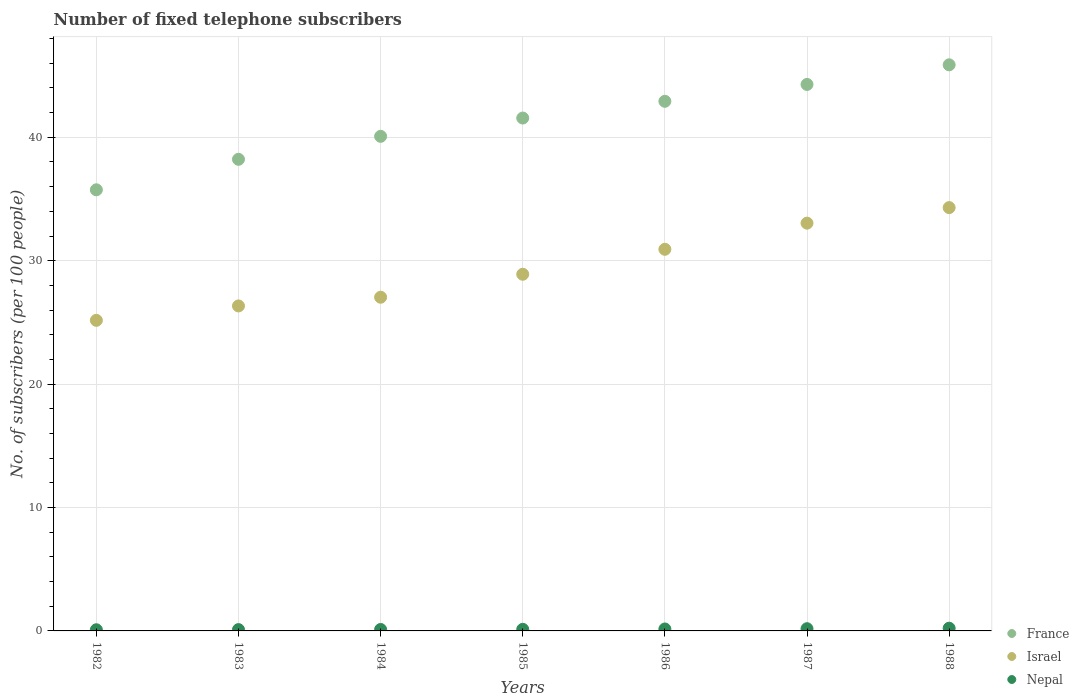Is the number of dotlines equal to the number of legend labels?
Offer a terse response. Yes. What is the number of fixed telephone subscribers in Nepal in 1986?
Make the answer very short. 0.16. Across all years, what is the maximum number of fixed telephone subscribers in Israel?
Your answer should be very brief. 34.3. Across all years, what is the minimum number of fixed telephone subscribers in Israel?
Offer a terse response. 25.17. What is the total number of fixed telephone subscribers in France in the graph?
Your answer should be compact. 288.67. What is the difference between the number of fixed telephone subscribers in France in 1985 and that in 1987?
Offer a very short reply. -2.72. What is the difference between the number of fixed telephone subscribers in Israel in 1988 and the number of fixed telephone subscribers in France in 1983?
Your answer should be very brief. -3.91. What is the average number of fixed telephone subscribers in Nepal per year?
Your response must be concise. 0.14. In the year 1985, what is the difference between the number of fixed telephone subscribers in Nepal and number of fixed telephone subscribers in France?
Make the answer very short. -41.43. What is the ratio of the number of fixed telephone subscribers in Nepal in 1982 to that in 1983?
Provide a short and direct response. 0.89. Is the difference between the number of fixed telephone subscribers in Nepal in 1982 and 1985 greater than the difference between the number of fixed telephone subscribers in France in 1982 and 1985?
Make the answer very short. Yes. What is the difference between the highest and the second highest number of fixed telephone subscribers in France?
Your answer should be compact. 1.59. What is the difference between the highest and the lowest number of fixed telephone subscribers in France?
Keep it short and to the point. 10.13. In how many years, is the number of fixed telephone subscribers in France greater than the average number of fixed telephone subscribers in France taken over all years?
Provide a succinct answer. 4. Is the sum of the number of fixed telephone subscribers in France in 1984 and 1986 greater than the maximum number of fixed telephone subscribers in Nepal across all years?
Your answer should be very brief. Yes. How many dotlines are there?
Your answer should be compact. 3. Are the values on the major ticks of Y-axis written in scientific E-notation?
Your answer should be compact. No. Does the graph contain any zero values?
Your answer should be very brief. No. What is the title of the graph?
Offer a very short reply. Number of fixed telephone subscribers. Does "Saudi Arabia" appear as one of the legend labels in the graph?
Offer a very short reply. No. What is the label or title of the Y-axis?
Make the answer very short. No. of subscribers (per 100 people). What is the No. of subscribers (per 100 people) of France in 1982?
Make the answer very short. 35.75. What is the No. of subscribers (per 100 people) in Israel in 1982?
Your answer should be very brief. 25.17. What is the No. of subscribers (per 100 people) in Nepal in 1982?
Make the answer very short. 0.09. What is the No. of subscribers (per 100 people) in France in 1983?
Keep it short and to the point. 38.22. What is the No. of subscribers (per 100 people) of Israel in 1983?
Provide a succinct answer. 26.34. What is the No. of subscribers (per 100 people) of Nepal in 1983?
Your answer should be very brief. 0.11. What is the No. of subscribers (per 100 people) of France in 1984?
Your answer should be very brief. 40.08. What is the No. of subscribers (per 100 people) in Israel in 1984?
Your answer should be compact. 27.04. What is the No. of subscribers (per 100 people) in Nepal in 1984?
Give a very brief answer. 0.12. What is the No. of subscribers (per 100 people) of France in 1985?
Give a very brief answer. 41.56. What is the No. of subscribers (per 100 people) of Israel in 1985?
Keep it short and to the point. 28.9. What is the No. of subscribers (per 100 people) of Nepal in 1985?
Provide a succinct answer. 0.13. What is the No. of subscribers (per 100 people) of France in 1986?
Give a very brief answer. 42.92. What is the No. of subscribers (per 100 people) in Israel in 1986?
Provide a succinct answer. 30.92. What is the No. of subscribers (per 100 people) of Nepal in 1986?
Offer a very short reply. 0.16. What is the No. of subscribers (per 100 people) in France in 1987?
Ensure brevity in your answer.  44.28. What is the No. of subscribers (per 100 people) of Israel in 1987?
Ensure brevity in your answer.  33.04. What is the No. of subscribers (per 100 people) in Nepal in 1987?
Keep it short and to the point. 0.18. What is the No. of subscribers (per 100 people) of France in 1988?
Offer a very short reply. 45.87. What is the No. of subscribers (per 100 people) of Israel in 1988?
Ensure brevity in your answer.  34.3. What is the No. of subscribers (per 100 people) of Nepal in 1988?
Offer a very short reply. 0.22. Across all years, what is the maximum No. of subscribers (per 100 people) of France?
Provide a succinct answer. 45.87. Across all years, what is the maximum No. of subscribers (per 100 people) of Israel?
Offer a terse response. 34.3. Across all years, what is the maximum No. of subscribers (per 100 people) in Nepal?
Your answer should be compact. 0.22. Across all years, what is the minimum No. of subscribers (per 100 people) in France?
Your response must be concise. 35.75. Across all years, what is the minimum No. of subscribers (per 100 people) of Israel?
Make the answer very short. 25.17. Across all years, what is the minimum No. of subscribers (per 100 people) in Nepal?
Your answer should be compact. 0.09. What is the total No. of subscribers (per 100 people) of France in the graph?
Keep it short and to the point. 288.67. What is the total No. of subscribers (per 100 people) of Israel in the graph?
Provide a short and direct response. 205.72. What is the difference between the No. of subscribers (per 100 people) in France in 1982 and that in 1983?
Your answer should be compact. -2.47. What is the difference between the No. of subscribers (per 100 people) of Israel in 1982 and that in 1983?
Provide a short and direct response. -1.17. What is the difference between the No. of subscribers (per 100 people) of Nepal in 1982 and that in 1983?
Offer a terse response. -0.01. What is the difference between the No. of subscribers (per 100 people) of France in 1982 and that in 1984?
Your answer should be very brief. -4.33. What is the difference between the No. of subscribers (per 100 people) in Israel in 1982 and that in 1984?
Your response must be concise. -1.87. What is the difference between the No. of subscribers (per 100 people) in Nepal in 1982 and that in 1984?
Give a very brief answer. -0.02. What is the difference between the No. of subscribers (per 100 people) of France in 1982 and that in 1985?
Offer a very short reply. -5.82. What is the difference between the No. of subscribers (per 100 people) in Israel in 1982 and that in 1985?
Make the answer very short. -3.73. What is the difference between the No. of subscribers (per 100 people) in Nepal in 1982 and that in 1985?
Ensure brevity in your answer.  -0.03. What is the difference between the No. of subscribers (per 100 people) of France in 1982 and that in 1986?
Give a very brief answer. -7.17. What is the difference between the No. of subscribers (per 100 people) of Israel in 1982 and that in 1986?
Offer a terse response. -5.76. What is the difference between the No. of subscribers (per 100 people) of Nepal in 1982 and that in 1986?
Offer a terse response. -0.06. What is the difference between the No. of subscribers (per 100 people) in France in 1982 and that in 1987?
Your answer should be compact. -8.54. What is the difference between the No. of subscribers (per 100 people) of Israel in 1982 and that in 1987?
Your answer should be very brief. -7.88. What is the difference between the No. of subscribers (per 100 people) of Nepal in 1982 and that in 1987?
Ensure brevity in your answer.  -0.09. What is the difference between the No. of subscribers (per 100 people) in France in 1982 and that in 1988?
Offer a very short reply. -10.13. What is the difference between the No. of subscribers (per 100 people) of Israel in 1982 and that in 1988?
Your answer should be compact. -9.14. What is the difference between the No. of subscribers (per 100 people) of Nepal in 1982 and that in 1988?
Your answer should be compact. -0.13. What is the difference between the No. of subscribers (per 100 people) of France in 1983 and that in 1984?
Your answer should be compact. -1.86. What is the difference between the No. of subscribers (per 100 people) of Israel in 1983 and that in 1984?
Offer a very short reply. -0.71. What is the difference between the No. of subscribers (per 100 people) in Nepal in 1983 and that in 1984?
Make the answer very short. -0.01. What is the difference between the No. of subscribers (per 100 people) of France in 1983 and that in 1985?
Make the answer very short. -3.34. What is the difference between the No. of subscribers (per 100 people) in Israel in 1983 and that in 1985?
Offer a very short reply. -2.57. What is the difference between the No. of subscribers (per 100 people) of Nepal in 1983 and that in 1985?
Provide a succinct answer. -0.02. What is the difference between the No. of subscribers (per 100 people) of France in 1983 and that in 1986?
Make the answer very short. -4.7. What is the difference between the No. of subscribers (per 100 people) in Israel in 1983 and that in 1986?
Give a very brief answer. -4.59. What is the difference between the No. of subscribers (per 100 people) in Nepal in 1983 and that in 1986?
Your response must be concise. -0.05. What is the difference between the No. of subscribers (per 100 people) in France in 1983 and that in 1987?
Ensure brevity in your answer.  -6.07. What is the difference between the No. of subscribers (per 100 people) of Israel in 1983 and that in 1987?
Your answer should be very brief. -6.71. What is the difference between the No. of subscribers (per 100 people) of Nepal in 1983 and that in 1987?
Give a very brief answer. -0.07. What is the difference between the No. of subscribers (per 100 people) in France in 1983 and that in 1988?
Keep it short and to the point. -7.66. What is the difference between the No. of subscribers (per 100 people) in Israel in 1983 and that in 1988?
Ensure brevity in your answer.  -7.97. What is the difference between the No. of subscribers (per 100 people) of Nepal in 1983 and that in 1988?
Ensure brevity in your answer.  -0.11. What is the difference between the No. of subscribers (per 100 people) in France in 1984 and that in 1985?
Make the answer very short. -1.48. What is the difference between the No. of subscribers (per 100 people) in Israel in 1984 and that in 1985?
Make the answer very short. -1.86. What is the difference between the No. of subscribers (per 100 people) in Nepal in 1984 and that in 1985?
Offer a terse response. -0.01. What is the difference between the No. of subscribers (per 100 people) of France in 1984 and that in 1986?
Ensure brevity in your answer.  -2.84. What is the difference between the No. of subscribers (per 100 people) in Israel in 1984 and that in 1986?
Provide a short and direct response. -3.88. What is the difference between the No. of subscribers (per 100 people) of Nepal in 1984 and that in 1986?
Your response must be concise. -0.04. What is the difference between the No. of subscribers (per 100 people) in France in 1984 and that in 1987?
Offer a very short reply. -4.21. What is the difference between the No. of subscribers (per 100 people) of Israel in 1984 and that in 1987?
Ensure brevity in your answer.  -6. What is the difference between the No. of subscribers (per 100 people) in Nepal in 1984 and that in 1987?
Your response must be concise. -0.06. What is the difference between the No. of subscribers (per 100 people) in France in 1984 and that in 1988?
Offer a very short reply. -5.8. What is the difference between the No. of subscribers (per 100 people) of Israel in 1984 and that in 1988?
Your answer should be very brief. -7.26. What is the difference between the No. of subscribers (per 100 people) of Nepal in 1984 and that in 1988?
Your answer should be compact. -0.1. What is the difference between the No. of subscribers (per 100 people) in France in 1985 and that in 1986?
Make the answer very short. -1.36. What is the difference between the No. of subscribers (per 100 people) in Israel in 1985 and that in 1986?
Provide a short and direct response. -2.02. What is the difference between the No. of subscribers (per 100 people) in Nepal in 1985 and that in 1986?
Provide a succinct answer. -0.03. What is the difference between the No. of subscribers (per 100 people) in France in 1985 and that in 1987?
Your answer should be compact. -2.72. What is the difference between the No. of subscribers (per 100 people) in Israel in 1985 and that in 1987?
Keep it short and to the point. -4.14. What is the difference between the No. of subscribers (per 100 people) of Nepal in 1985 and that in 1987?
Keep it short and to the point. -0.05. What is the difference between the No. of subscribers (per 100 people) of France in 1985 and that in 1988?
Provide a short and direct response. -4.31. What is the difference between the No. of subscribers (per 100 people) in Israel in 1985 and that in 1988?
Give a very brief answer. -5.4. What is the difference between the No. of subscribers (per 100 people) in Nepal in 1985 and that in 1988?
Keep it short and to the point. -0.09. What is the difference between the No. of subscribers (per 100 people) of France in 1986 and that in 1987?
Provide a short and direct response. -1.37. What is the difference between the No. of subscribers (per 100 people) of Israel in 1986 and that in 1987?
Offer a very short reply. -2.12. What is the difference between the No. of subscribers (per 100 people) of Nepal in 1986 and that in 1987?
Ensure brevity in your answer.  -0.02. What is the difference between the No. of subscribers (per 100 people) of France in 1986 and that in 1988?
Your answer should be compact. -2.96. What is the difference between the No. of subscribers (per 100 people) in Israel in 1986 and that in 1988?
Offer a terse response. -3.38. What is the difference between the No. of subscribers (per 100 people) of Nepal in 1986 and that in 1988?
Make the answer very short. -0.06. What is the difference between the No. of subscribers (per 100 people) in France in 1987 and that in 1988?
Your answer should be compact. -1.59. What is the difference between the No. of subscribers (per 100 people) in Israel in 1987 and that in 1988?
Offer a very short reply. -1.26. What is the difference between the No. of subscribers (per 100 people) in Nepal in 1987 and that in 1988?
Provide a succinct answer. -0.04. What is the difference between the No. of subscribers (per 100 people) in France in 1982 and the No. of subscribers (per 100 people) in Israel in 1983?
Ensure brevity in your answer.  9.41. What is the difference between the No. of subscribers (per 100 people) of France in 1982 and the No. of subscribers (per 100 people) of Nepal in 1983?
Your response must be concise. 35.64. What is the difference between the No. of subscribers (per 100 people) in Israel in 1982 and the No. of subscribers (per 100 people) in Nepal in 1983?
Give a very brief answer. 25.06. What is the difference between the No. of subscribers (per 100 people) in France in 1982 and the No. of subscribers (per 100 people) in Israel in 1984?
Ensure brevity in your answer.  8.7. What is the difference between the No. of subscribers (per 100 people) in France in 1982 and the No. of subscribers (per 100 people) in Nepal in 1984?
Make the answer very short. 35.63. What is the difference between the No. of subscribers (per 100 people) of Israel in 1982 and the No. of subscribers (per 100 people) of Nepal in 1984?
Your answer should be compact. 25.05. What is the difference between the No. of subscribers (per 100 people) of France in 1982 and the No. of subscribers (per 100 people) of Israel in 1985?
Provide a short and direct response. 6.84. What is the difference between the No. of subscribers (per 100 people) in France in 1982 and the No. of subscribers (per 100 people) in Nepal in 1985?
Provide a short and direct response. 35.62. What is the difference between the No. of subscribers (per 100 people) of Israel in 1982 and the No. of subscribers (per 100 people) of Nepal in 1985?
Keep it short and to the point. 25.04. What is the difference between the No. of subscribers (per 100 people) of France in 1982 and the No. of subscribers (per 100 people) of Israel in 1986?
Offer a very short reply. 4.82. What is the difference between the No. of subscribers (per 100 people) in France in 1982 and the No. of subscribers (per 100 people) in Nepal in 1986?
Your response must be concise. 35.59. What is the difference between the No. of subscribers (per 100 people) of Israel in 1982 and the No. of subscribers (per 100 people) of Nepal in 1986?
Keep it short and to the point. 25.01. What is the difference between the No. of subscribers (per 100 people) in France in 1982 and the No. of subscribers (per 100 people) in Israel in 1987?
Provide a short and direct response. 2.7. What is the difference between the No. of subscribers (per 100 people) in France in 1982 and the No. of subscribers (per 100 people) in Nepal in 1987?
Keep it short and to the point. 35.57. What is the difference between the No. of subscribers (per 100 people) of Israel in 1982 and the No. of subscribers (per 100 people) of Nepal in 1987?
Your answer should be very brief. 24.99. What is the difference between the No. of subscribers (per 100 people) in France in 1982 and the No. of subscribers (per 100 people) in Israel in 1988?
Make the answer very short. 1.44. What is the difference between the No. of subscribers (per 100 people) in France in 1982 and the No. of subscribers (per 100 people) in Nepal in 1988?
Ensure brevity in your answer.  35.53. What is the difference between the No. of subscribers (per 100 people) of Israel in 1982 and the No. of subscribers (per 100 people) of Nepal in 1988?
Provide a succinct answer. 24.95. What is the difference between the No. of subscribers (per 100 people) of France in 1983 and the No. of subscribers (per 100 people) of Israel in 1984?
Provide a succinct answer. 11.18. What is the difference between the No. of subscribers (per 100 people) of France in 1983 and the No. of subscribers (per 100 people) of Nepal in 1984?
Your response must be concise. 38.1. What is the difference between the No. of subscribers (per 100 people) in Israel in 1983 and the No. of subscribers (per 100 people) in Nepal in 1984?
Your answer should be very brief. 26.22. What is the difference between the No. of subscribers (per 100 people) in France in 1983 and the No. of subscribers (per 100 people) in Israel in 1985?
Offer a terse response. 9.32. What is the difference between the No. of subscribers (per 100 people) of France in 1983 and the No. of subscribers (per 100 people) of Nepal in 1985?
Give a very brief answer. 38.09. What is the difference between the No. of subscribers (per 100 people) in Israel in 1983 and the No. of subscribers (per 100 people) in Nepal in 1985?
Offer a very short reply. 26.21. What is the difference between the No. of subscribers (per 100 people) of France in 1983 and the No. of subscribers (per 100 people) of Israel in 1986?
Offer a terse response. 7.29. What is the difference between the No. of subscribers (per 100 people) of France in 1983 and the No. of subscribers (per 100 people) of Nepal in 1986?
Give a very brief answer. 38.06. What is the difference between the No. of subscribers (per 100 people) of Israel in 1983 and the No. of subscribers (per 100 people) of Nepal in 1986?
Keep it short and to the point. 26.18. What is the difference between the No. of subscribers (per 100 people) in France in 1983 and the No. of subscribers (per 100 people) in Israel in 1987?
Your answer should be compact. 5.17. What is the difference between the No. of subscribers (per 100 people) in France in 1983 and the No. of subscribers (per 100 people) in Nepal in 1987?
Offer a terse response. 38.04. What is the difference between the No. of subscribers (per 100 people) of Israel in 1983 and the No. of subscribers (per 100 people) of Nepal in 1987?
Offer a terse response. 26.16. What is the difference between the No. of subscribers (per 100 people) of France in 1983 and the No. of subscribers (per 100 people) of Israel in 1988?
Your answer should be compact. 3.91. What is the difference between the No. of subscribers (per 100 people) of France in 1983 and the No. of subscribers (per 100 people) of Nepal in 1988?
Make the answer very short. 38. What is the difference between the No. of subscribers (per 100 people) in Israel in 1983 and the No. of subscribers (per 100 people) in Nepal in 1988?
Your answer should be compact. 26.12. What is the difference between the No. of subscribers (per 100 people) in France in 1984 and the No. of subscribers (per 100 people) in Israel in 1985?
Keep it short and to the point. 11.18. What is the difference between the No. of subscribers (per 100 people) in France in 1984 and the No. of subscribers (per 100 people) in Nepal in 1985?
Provide a succinct answer. 39.95. What is the difference between the No. of subscribers (per 100 people) in Israel in 1984 and the No. of subscribers (per 100 people) in Nepal in 1985?
Offer a terse response. 26.91. What is the difference between the No. of subscribers (per 100 people) of France in 1984 and the No. of subscribers (per 100 people) of Israel in 1986?
Keep it short and to the point. 9.15. What is the difference between the No. of subscribers (per 100 people) in France in 1984 and the No. of subscribers (per 100 people) in Nepal in 1986?
Provide a short and direct response. 39.92. What is the difference between the No. of subscribers (per 100 people) in Israel in 1984 and the No. of subscribers (per 100 people) in Nepal in 1986?
Provide a short and direct response. 26.88. What is the difference between the No. of subscribers (per 100 people) in France in 1984 and the No. of subscribers (per 100 people) in Israel in 1987?
Your answer should be very brief. 7.03. What is the difference between the No. of subscribers (per 100 people) of France in 1984 and the No. of subscribers (per 100 people) of Nepal in 1987?
Give a very brief answer. 39.9. What is the difference between the No. of subscribers (per 100 people) in Israel in 1984 and the No. of subscribers (per 100 people) in Nepal in 1987?
Offer a terse response. 26.86. What is the difference between the No. of subscribers (per 100 people) of France in 1984 and the No. of subscribers (per 100 people) of Israel in 1988?
Provide a succinct answer. 5.77. What is the difference between the No. of subscribers (per 100 people) in France in 1984 and the No. of subscribers (per 100 people) in Nepal in 1988?
Your response must be concise. 39.86. What is the difference between the No. of subscribers (per 100 people) in Israel in 1984 and the No. of subscribers (per 100 people) in Nepal in 1988?
Make the answer very short. 26.82. What is the difference between the No. of subscribers (per 100 people) of France in 1985 and the No. of subscribers (per 100 people) of Israel in 1986?
Your answer should be very brief. 10.64. What is the difference between the No. of subscribers (per 100 people) of France in 1985 and the No. of subscribers (per 100 people) of Nepal in 1986?
Offer a very short reply. 41.4. What is the difference between the No. of subscribers (per 100 people) of Israel in 1985 and the No. of subscribers (per 100 people) of Nepal in 1986?
Provide a short and direct response. 28.74. What is the difference between the No. of subscribers (per 100 people) of France in 1985 and the No. of subscribers (per 100 people) of Israel in 1987?
Your answer should be very brief. 8.52. What is the difference between the No. of subscribers (per 100 people) in France in 1985 and the No. of subscribers (per 100 people) in Nepal in 1987?
Provide a short and direct response. 41.38. What is the difference between the No. of subscribers (per 100 people) in Israel in 1985 and the No. of subscribers (per 100 people) in Nepal in 1987?
Offer a very short reply. 28.72. What is the difference between the No. of subscribers (per 100 people) in France in 1985 and the No. of subscribers (per 100 people) in Israel in 1988?
Ensure brevity in your answer.  7.26. What is the difference between the No. of subscribers (per 100 people) in France in 1985 and the No. of subscribers (per 100 people) in Nepal in 1988?
Your response must be concise. 41.34. What is the difference between the No. of subscribers (per 100 people) of Israel in 1985 and the No. of subscribers (per 100 people) of Nepal in 1988?
Provide a short and direct response. 28.68. What is the difference between the No. of subscribers (per 100 people) of France in 1986 and the No. of subscribers (per 100 people) of Israel in 1987?
Provide a short and direct response. 9.87. What is the difference between the No. of subscribers (per 100 people) in France in 1986 and the No. of subscribers (per 100 people) in Nepal in 1987?
Provide a short and direct response. 42.74. What is the difference between the No. of subscribers (per 100 people) of Israel in 1986 and the No. of subscribers (per 100 people) of Nepal in 1987?
Provide a succinct answer. 30.74. What is the difference between the No. of subscribers (per 100 people) in France in 1986 and the No. of subscribers (per 100 people) in Israel in 1988?
Provide a short and direct response. 8.61. What is the difference between the No. of subscribers (per 100 people) of France in 1986 and the No. of subscribers (per 100 people) of Nepal in 1988?
Provide a succinct answer. 42.7. What is the difference between the No. of subscribers (per 100 people) in Israel in 1986 and the No. of subscribers (per 100 people) in Nepal in 1988?
Give a very brief answer. 30.7. What is the difference between the No. of subscribers (per 100 people) of France in 1987 and the No. of subscribers (per 100 people) of Israel in 1988?
Your answer should be very brief. 9.98. What is the difference between the No. of subscribers (per 100 people) in France in 1987 and the No. of subscribers (per 100 people) in Nepal in 1988?
Offer a terse response. 44.06. What is the difference between the No. of subscribers (per 100 people) in Israel in 1987 and the No. of subscribers (per 100 people) in Nepal in 1988?
Ensure brevity in your answer.  32.82. What is the average No. of subscribers (per 100 people) in France per year?
Offer a terse response. 41.24. What is the average No. of subscribers (per 100 people) in Israel per year?
Keep it short and to the point. 29.39. What is the average No. of subscribers (per 100 people) in Nepal per year?
Make the answer very short. 0.14. In the year 1982, what is the difference between the No. of subscribers (per 100 people) in France and No. of subscribers (per 100 people) in Israel?
Offer a very short reply. 10.58. In the year 1982, what is the difference between the No. of subscribers (per 100 people) of France and No. of subscribers (per 100 people) of Nepal?
Your answer should be compact. 35.65. In the year 1982, what is the difference between the No. of subscribers (per 100 people) of Israel and No. of subscribers (per 100 people) of Nepal?
Offer a very short reply. 25.07. In the year 1983, what is the difference between the No. of subscribers (per 100 people) in France and No. of subscribers (per 100 people) in Israel?
Offer a terse response. 11.88. In the year 1983, what is the difference between the No. of subscribers (per 100 people) of France and No. of subscribers (per 100 people) of Nepal?
Provide a succinct answer. 38.11. In the year 1983, what is the difference between the No. of subscribers (per 100 people) in Israel and No. of subscribers (per 100 people) in Nepal?
Provide a short and direct response. 26.23. In the year 1984, what is the difference between the No. of subscribers (per 100 people) in France and No. of subscribers (per 100 people) in Israel?
Your response must be concise. 13.04. In the year 1984, what is the difference between the No. of subscribers (per 100 people) of France and No. of subscribers (per 100 people) of Nepal?
Give a very brief answer. 39.96. In the year 1984, what is the difference between the No. of subscribers (per 100 people) in Israel and No. of subscribers (per 100 people) in Nepal?
Keep it short and to the point. 26.92. In the year 1985, what is the difference between the No. of subscribers (per 100 people) of France and No. of subscribers (per 100 people) of Israel?
Ensure brevity in your answer.  12.66. In the year 1985, what is the difference between the No. of subscribers (per 100 people) in France and No. of subscribers (per 100 people) in Nepal?
Keep it short and to the point. 41.43. In the year 1985, what is the difference between the No. of subscribers (per 100 people) in Israel and No. of subscribers (per 100 people) in Nepal?
Provide a short and direct response. 28.77. In the year 1986, what is the difference between the No. of subscribers (per 100 people) in France and No. of subscribers (per 100 people) in Israel?
Provide a succinct answer. 11.99. In the year 1986, what is the difference between the No. of subscribers (per 100 people) in France and No. of subscribers (per 100 people) in Nepal?
Offer a terse response. 42.76. In the year 1986, what is the difference between the No. of subscribers (per 100 people) in Israel and No. of subscribers (per 100 people) in Nepal?
Offer a terse response. 30.77. In the year 1987, what is the difference between the No. of subscribers (per 100 people) of France and No. of subscribers (per 100 people) of Israel?
Provide a short and direct response. 11.24. In the year 1987, what is the difference between the No. of subscribers (per 100 people) of France and No. of subscribers (per 100 people) of Nepal?
Make the answer very short. 44.1. In the year 1987, what is the difference between the No. of subscribers (per 100 people) of Israel and No. of subscribers (per 100 people) of Nepal?
Your answer should be very brief. 32.86. In the year 1988, what is the difference between the No. of subscribers (per 100 people) of France and No. of subscribers (per 100 people) of Israel?
Keep it short and to the point. 11.57. In the year 1988, what is the difference between the No. of subscribers (per 100 people) in France and No. of subscribers (per 100 people) in Nepal?
Provide a short and direct response. 45.65. In the year 1988, what is the difference between the No. of subscribers (per 100 people) of Israel and No. of subscribers (per 100 people) of Nepal?
Make the answer very short. 34.08. What is the ratio of the No. of subscribers (per 100 people) of France in 1982 to that in 1983?
Provide a succinct answer. 0.94. What is the ratio of the No. of subscribers (per 100 people) of Israel in 1982 to that in 1983?
Provide a short and direct response. 0.96. What is the ratio of the No. of subscribers (per 100 people) in Nepal in 1982 to that in 1983?
Your answer should be compact. 0.89. What is the ratio of the No. of subscribers (per 100 people) in France in 1982 to that in 1984?
Your answer should be very brief. 0.89. What is the ratio of the No. of subscribers (per 100 people) of Israel in 1982 to that in 1984?
Ensure brevity in your answer.  0.93. What is the ratio of the No. of subscribers (per 100 people) of Nepal in 1982 to that in 1984?
Ensure brevity in your answer.  0.81. What is the ratio of the No. of subscribers (per 100 people) in France in 1982 to that in 1985?
Ensure brevity in your answer.  0.86. What is the ratio of the No. of subscribers (per 100 people) in Israel in 1982 to that in 1985?
Provide a succinct answer. 0.87. What is the ratio of the No. of subscribers (per 100 people) of Nepal in 1982 to that in 1985?
Give a very brief answer. 0.74. What is the ratio of the No. of subscribers (per 100 people) of France in 1982 to that in 1986?
Offer a very short reply. 0.83. What is the ratio of the No. of subscribers (per 100 people) of Israel in 1982 to that in 1986?
Your answer should be compact. 0.81. What is the ratio of the No. of subscribers (per 100 people) in Nepal in 1982 to that in 1986?
Offer a very short reply. 0.6. What is the ratio of the No. of subscribers (per 100 people) in France in 1982 to that in 1987?
Provide a short and direct response. 0.81. What is the ratio of the No. of subscribers (per 100 people) in Israel in 1982 to that in 1987?
Offer a very short reply. 0.76. What is the ratio of the No. of subscribers (per 100 people) in Nepal in 1982 to that in 1987?
Provide a succinct answer. 0.53. What is the ratio of the No. of subscribers (per 100 people) of France in 1982 to that in 1988?
Your response must be concise. 0.78. What is the ratio of the No. of subscribers (per 100 people) of Israel in 1982 to that in 1988?
Keep it short and to the point. 0.73. What is the ratio of the No. of subscribers (per 100 people) of Nepal in 1982 to that in 1988?
Provide a short and direct response. 0.43. What is the ratio of the No. of subscribers (per 100 people) of France in 1983 to that in 1984?
Keep it short and to the point. 0.95. What is the ratio of the No. of subscribers (per 100 people) in Israel in 1983 to that in 1984?
Make the answer very short. 0.97. What is the ratio of the No. of subscribers (per 100 people) of Nepal in 1983 to that in 1984?
Make the answer very short. 0.91. What is the ratio of the No. of subscribers (per 100 people) in France in 1983 to that in 1985?
Provide a short and direct response. 0.92. What is the ratio of the No. of subscribers (per 100 people) in Israel in 1983 to that in 1985?
Make the answer very short. 0.91. What is the ratio of the No. of subscribers (per 100 people) of Nepal in 1983 to that in 1985?
Make the answer very short. 0.83. What is the ratio of the No. of subscribers (per 100 people) in France in 1983 to that in 1986?
Provide a succinct answer. 0.89. What is the ratio of the No. of subscribers (per 100 people) of Israel in 1983 to that in 1986?
Your answer should be very brief. 0.85. What is the ratio of the No. of subscribers (per 100 people) in Nepal in 1983 to that in 1986?
Offer a very short reply. 0.68. What is the ratio of the No. of subscribers (per 100 people) of France in 1983 to that in 1987?
Keep it short and to the point. 0.86. What is the ratio of the No. of subscribers (per 100 people) of Israel in 1983 to that in 1987?
Provide a succinct answer. 0.8. What is the ratio of the No. of subscribers (per 100 people) in Nepal in 1983 to that in 1987?
Offer a terse response. 0.59. What is the ratio of the No. of subscribers (per 100 people) in France in 1983 to that in 1988?
Make the answer very short. 0.83. What is the ratio of the No. of subscribers (per 100 people) of Israel in 1983 to that in 1988?
Provide a short and direct response. 0.77. What is the ratio of the No. of subscribers (per 100 people) in Nepal in 1983 to that in 1988?
Offer a terse response. 0.49. What is the ratio of the No. of subscribers (per 100 people) in France in 1984 to that in 1985?
Provide a short and direct response. 0.96. What is the ratio of the No. of subscribers (per 100 people) in Israel in 1984 to that in 1985?
Your answer should be very brief. 0.94. What is the ratio of the No. of subscribers (per 100 people) in Nepal in 1984 to that in 1985?
Offer a terse response. 0.92. What is the ratio of the No. of subscribers (per 100 people) of France in 1984 to that in 1986?
Your answer should be compact. 0.93. What is the ratio of the No. of subscribers (per 100 people) in Israel in 1984 to that in 1986?
Give a very brief answer. 0.87. What is the ratio of the No. of subscribers (per 100 people) of Nepal in 1984 to that in 1986?
Make the answer very short. 0.75. What is the ratio of the No. of subscribers (per 100 people) in France in 1984 to that in 1987?
Your response must be concise. 0.91. What is the ratio of the No. of subscribers (per 100 people) in Israel in 1984 to that in 1987?
Your answer should be compact. 0.82. What is the ratio of the No. of subscribers (per 100 people) of Nepal in 1984 to that in 1987?
Offer a terse response. 0.65. What is the ratio of the No. of subscribers (per 100 people) of France in 1984 to that in 1988?
Offer a very short reply. 0.87. What is the ratio of the No. of subscribers (per 100 people) in Israel in 1984 to that in 1988?
Provide a short and direct response. 0.79. What is the ratio of the No. of subscribers (per 100 people) in Nepal in 1984 to that in 1988?
Make the answer very short. 0.54. What is the ratio of the No. of subscribers (per 100 people) of France in 1985 to that in 1986?
Your answer should be compact. 0.97. What is the ratio of the No. of subscribers (per 100 people) of Israel in 1985 to that in 1986?
Ensure brevity in your answer.  0.93. What is the ratio of the No. of subscribers (per 100 people) in Nepal in 1985 to that in 1986?
Ensure brevity in your answer.  0.81. What is the ratio of the No. of subscribers (per 100 people) of France in 1985 to that in 1987?
Offer a very short reply. 0.94. What is the ratio of the No. of subscribers (per 100 people) in Israel in 1985 to that in 1987?
Your answer should be compact. 0.87. What is the ratio of the No. of subscribers (per 100 people) of Nepal in 1985 to that in 1987?
Provide a short and direct response. 0.71. What is the ratio of the No. of subscribers (per 100 people) in France in 1985 to that in 1988?
Ensure brevity in your answer.  0.91. What is the ratio of the No. of subscribers (per 100 people) in Israel in 1985 to that in 1988?
Ensure brevity in your answer.  0.84. What is the ratio of the No. of subscribers (per 100 people) of Nepal in 1985 to that in 1988?
Keep it short and to the point. 0.58. What is the ratio of the No. of subscribers (per 100 people) of France in 1986 to that in 1987?
Provide a succinct answer. 0.97. What is the ratio of the No. of subscribers (per 100 people) of Israel in 1986 to that in 1987?
Your answer should be compact. 0.94. What is the ratio of the No. of subscribers (per 100 people) in Nepal in 1986 to that in 1987?
Ensure brevity in your answer.  0.87. What is the ratio of the No. of subscribers (per 100 people) in France in 1986 to that in 1988?
Your answer should be very brief. 0.94. What is the ratio of the No. of subscribers (per 100 people) in Israel in 1986 to that in 1988?
Offer a terse response. 0.9. What is the ratio of the No. of subscribers (per 100 people) in Nepal in 1986 to that in 1988?
Your answer should be compact. 0.72. What is the ratio of the No. of subscribers (per 100 people) of France in 1987 to that in 1988?
Keep it short and to the point. 0.97. What is the ratio of the No. of subscribers (per 100 people) of Israel in 1987 to that in 1988?
Offer a very short reply. 0.96. What is the ratio of the No. of subscribers (per 100 people) of Nepal in 1987 to that in 1988?
Offer a terse response. 0.82. What is the difference between the highest and the second highest No. of subscribers (per 100 people) of France?
Provide a short and direct response. 1.59. What is the difference between the highest and the second highest No. of subscribers (per 100 people) of Israel?
Your response must be concise. 1.26. What is the difference between the highest and the lowest No. of subscribers (per 100 people) in France?
Keep it short and to the point. 10.13. What is the difference between the highest and the lowest No. of subscribers (per 100 people) in Israel?
Ensure brevity in your answer.  9.14. What is the difference between the highest and the lowest No. of subscribers (per 100 people) in Nepal?
Give a very brief answer. 0.13. 